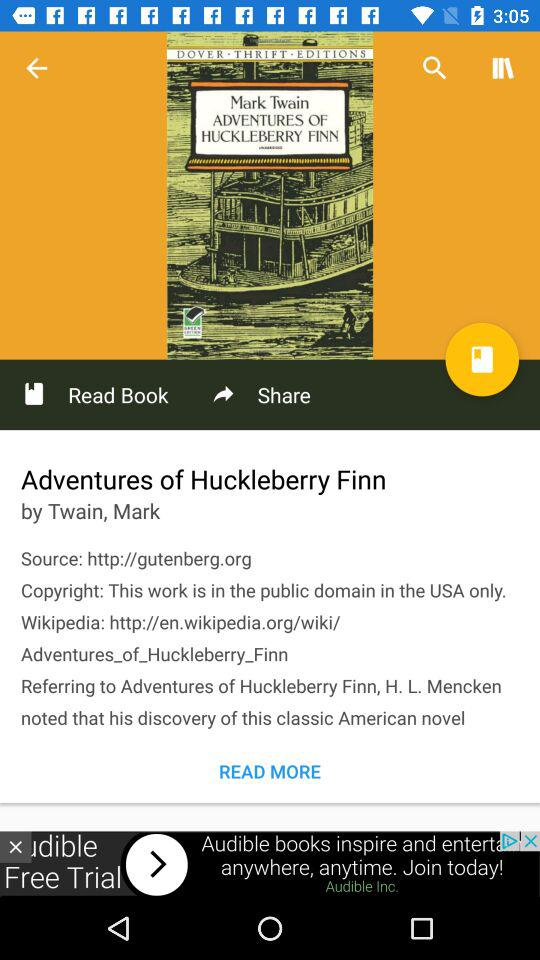Who is the author? The author is Mark Twain. 